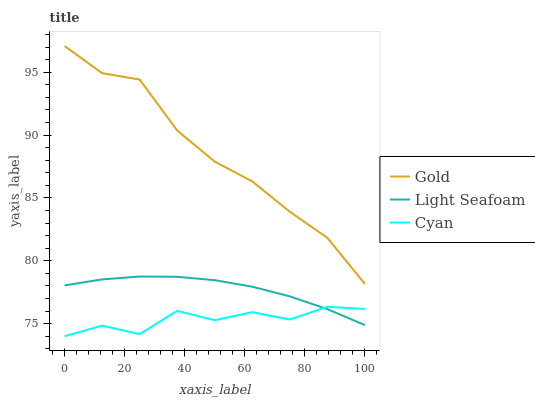Does Cyan have the minimum area under the curve?
Answer yes or no. Yes. Does Gold have the maximum area under the curve?
Answer yes or no. Yes. Does Light Seafoam have the minimum area under the curve?
Answer yes or no. No. Does Light Seafoam have the maximum area under the curve?
Answer yes or no. No. Is Light Seafoam the smoothest?
Answer yes or no. Yes. Is Cyan the roughest?
Answer yes or no. Yes. Is Gold the smoothest?
Answer yes or no. No. Is Gold the roughest?
Answer yes or no. No. Does Cyan have the lowest value?
Answer yes or no. Yes. Does Light Seafoam have the lowest value?
Answer yes or no. No. Does Gold have the highest value?
Answer yes or no. Yes. Does Light Seafoam have the highest value?
Answer yes or no. No. Is Cyan less than Gold?
Answer yes or no. Yes. Is Gold greater than Light Seafoam?
Answer yes or no. Yes. Does Cyan intersect Light Seafoam?
Answer yes or no. Yes. Is Cyan less than Light Seafoam?
Answer yes or no. No. Is Cyan greater than Light Seafoam?
Answer yes or no. No. Does Cyan intersect Gold?
Answer yes or no. No. 